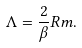Convert formula to latex. <formula><loc_0><loc_0><loc_500><loc_500>\Lambda = \frac { 2 } { \beta } R m .</formula> 